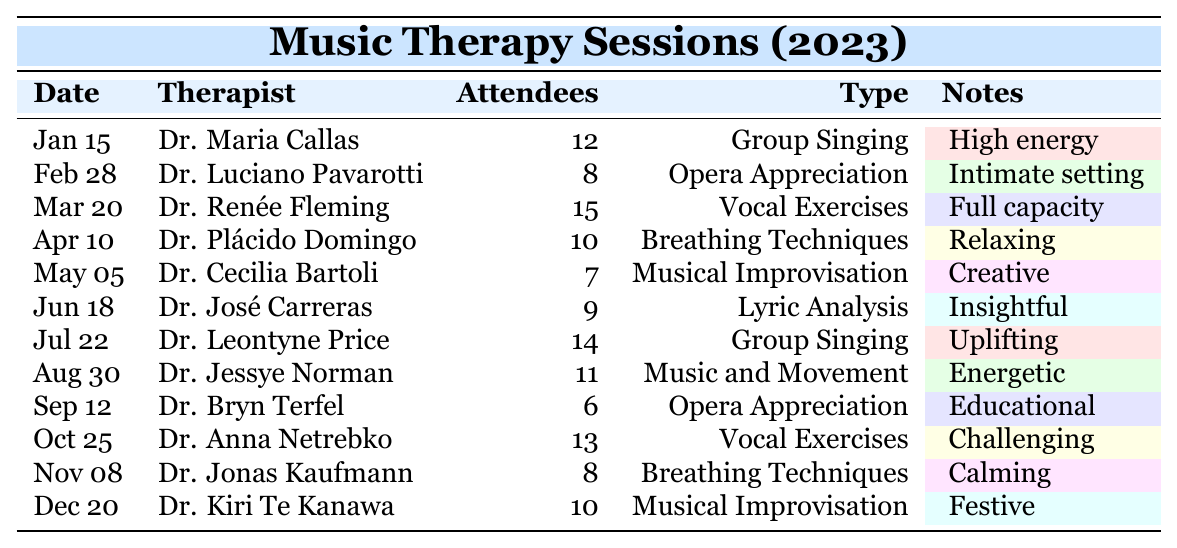What is the date of the "Musical Improvisation" session conducted by Dr. Cecilia Bartoli? The table shows that Dr. Cecilia Bartoli conducted the "Musical Improvisation" session on May 5, 2023.
Answer: May 5, 2023 Who was the therapist for the "Vocal Exercises" on October 25? According to the table, Dr. Anna Netrebko was the therapist who conducted "Vocal Exercises" on October 25, 2023.
Answer: Dr. Anna Netrebko How many attendees were present during the "Opera Appreciation" sessions? There were two "Opera Appreciation" sessions: one on February 28 with 8 attendees and another on September 12 with 6 attendees. The total number of attendees is 8 + 6 = 14.
Answer: 14 Which session had the highest number of attendees and what type was it? The session on March 20 conducted by Dr. Renée Fleming had the highest attendance with 15 attendees, and it was a "Vocal Exercises" session.
Answer: 15 attendees, Vocal Exercises Is there a trend in the number of attendees for "Breathing Techniques" sessions throughout the year? There are two "Breathing Techniques" sessions in the table: one on April 10 with 10 attendees and another on November 8 with 8 attendees. Since the numbers decreased from 10 to 8, there is a downward trend.
Answer: Yes, downward trend What is the average attendance for all the sessions conducted this year? Adding all the attendees together: 12 + 8 + 15 + 10 + 7 + 9 + 14 + 11 + 6 + 13 + 8 + 10 =  127. There are 12 sessions, so the average attendance is 127 / 12 = approximately 10.58.
Answer: Approx. 10.58 How many more attendees were present in the "Group Singing" sessions compared to "Opera Appreciation"? The "Group Singing" sessions had 12 attendees on January 15 and 14 attendees on July 22, resulting in a total of 12 + 14 = 26. The "Opera Appreciation" sessions had 8 + 6 = 14 attendees. The difference is 26 - 14 = 12.
Answer: 12 more attendees Did any session in December have fewer attendees than the one in June? The session in June (June 18) had 9 attendees, while the session in December (December 20) had 10 attendees. Since 10 is greater than 9, no session in December had fewer attendees than in June.
Answer: No 